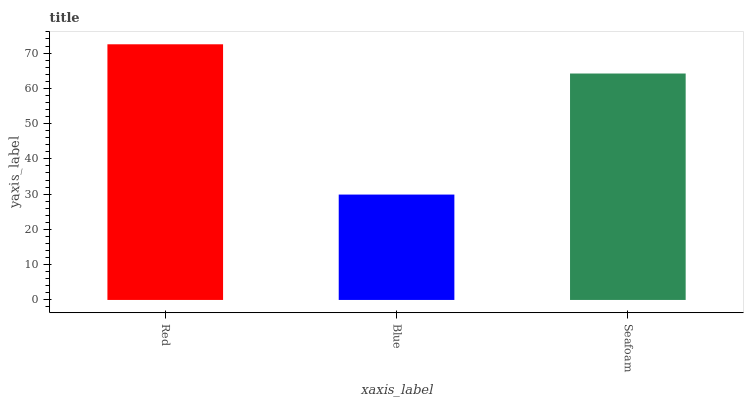Is Blue the minimum?
Answer yes or no. Yes. Is Red the maximum?
Answer yes or no. Yes. Is Seafoam the minimum?
Answer yes or no. No. Is Seafoam the maximum?
Answer yes or no. No. Is Seafoam greater than Blue?
Answer yes or no. Yes. Is Blue less than Seafoam?
Answer yes or no. Yes. Is Blue greater than Seafoam?
Answer yes or no. No. Is Seafoam less than Blue?
Answer yes or no. No. Is Seafoam the high median?
Answer yes or no. Yes. Is Seafoam the low median?
Answer yes or no. Yes. Is Blue the high median?
Answer yes or no. No. Is Red the low median?
Answer yes or no. No. 